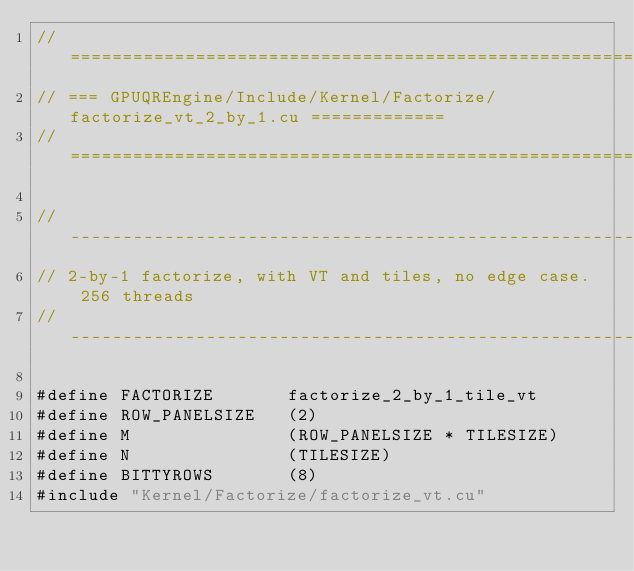Convert code to text. <code><loc_0><loc_0><loc_500><loc_500><_Cuda_>// =============================================================================
// === GPUQREngine/Include/Kernel/Factorize/factorize_vt_2_by_1.cu =============
// =============================================================================

//------------------------------------------------------------------------------
// 2-by-1 factorize, with VT and tiles, no edge case.  256 threads
//------------------------------------------------------------------------------

#define FACTORIZE       factorize_2_by_1_tile_vt
#define ROW_PANELSIZE   (2)
#define M               (ROW_PANELSIZE * TILESIZE)
#define N               (TILESIZE)
#define BITTYROWS       (8)
#include "Kernel/Factorize/factorize_vt.cu"
</code> 